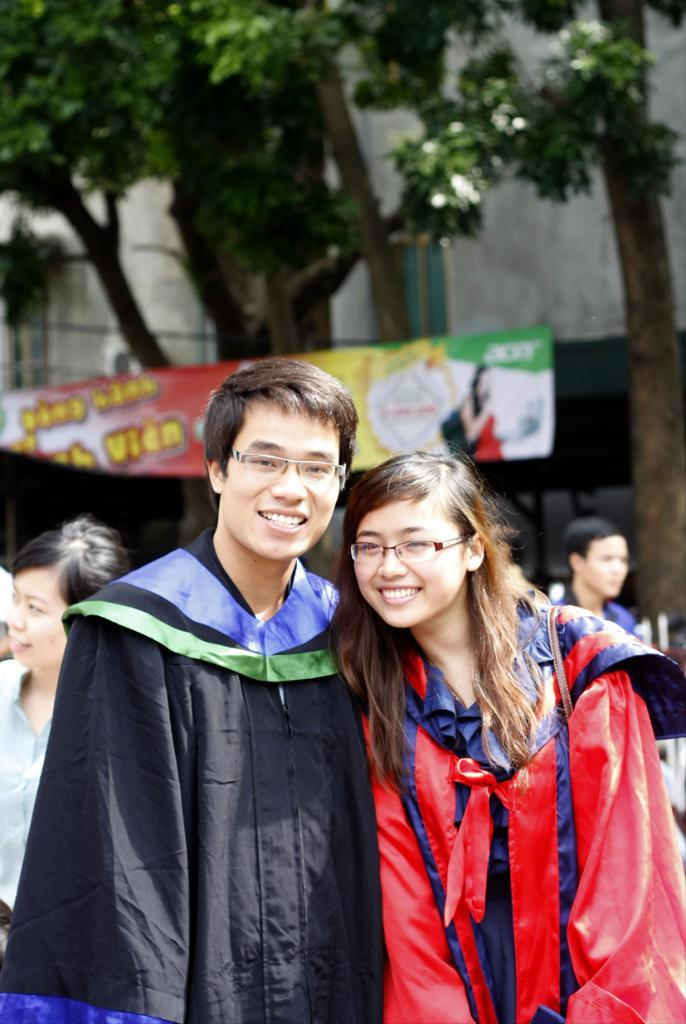What are the two main subjects in the foreground of the image? There is a man in a black coat and a woman in a red color in the foreground of the image. Can you describe the people in the background of the image? There are persons in the background of the image, but their specific characteristics are not mentioned in the facts. What can be seen in the background of the image besides the persons? There are trees and a banner in the background of the image. Who is the creator of the banner in the image? The facts do not mention the creator of the banner, so it cannot be determined from the image. What type of stove is visible in the image? There is no stove present in the image. 